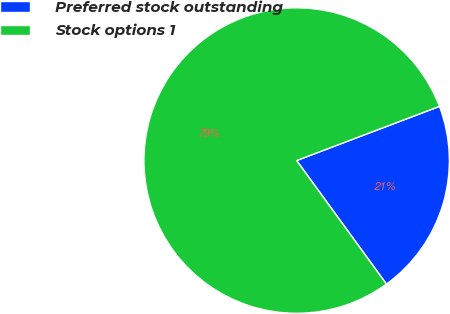Convert chart. <chart><loc_0><loc_0><loc_500><loc_500><pie_chart><fcel>Preferred stock outstanding<fcel>Stock options 1<nl><fcel>20.77%<fcel>79.23%<nl></chart> 